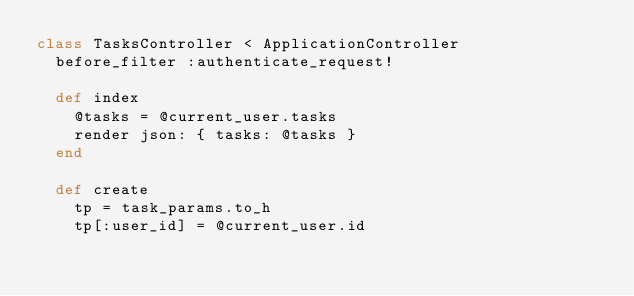Convert code to text. <code><loc_0><loc_0><loc_500><loc_500><_Ruby_>class TasksController < ApplicationController
  before_filter :authenticate_request!

  def index
    @tasks = @current_user.tasks
    render json: { tasks: @tasks }
  end

  def create
    tp = task_params.to_h
    tp[:user_id] = @current_user.id
</code> 